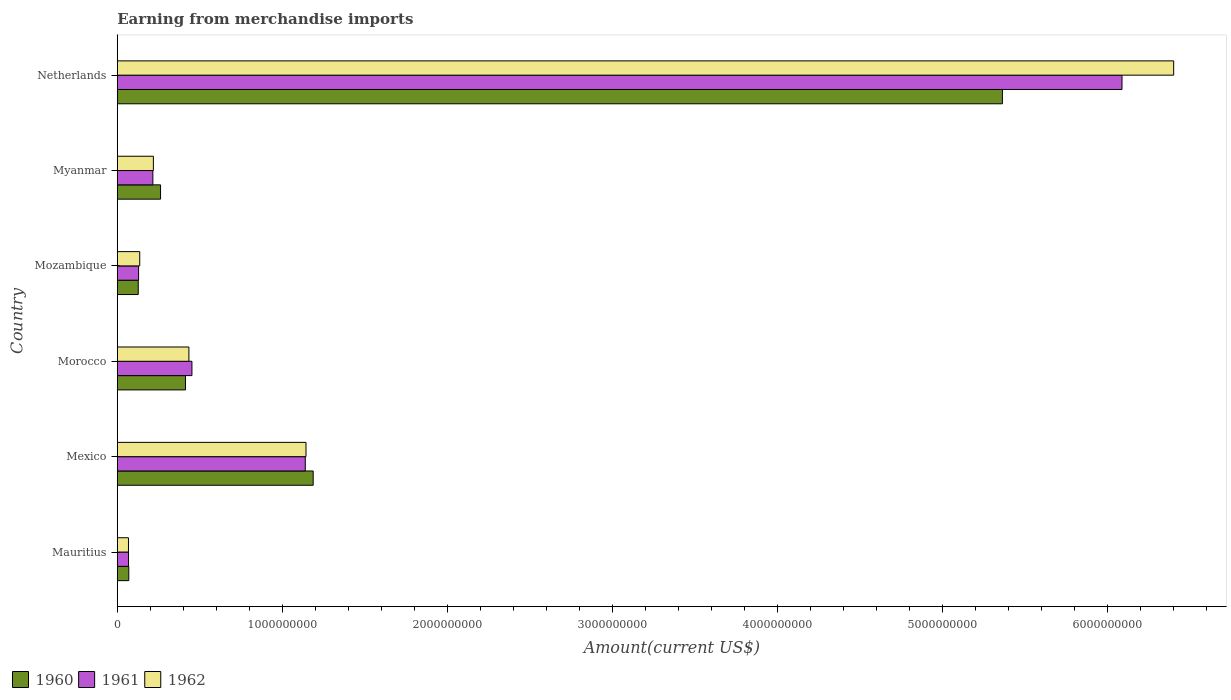How many different coloured bars are there?
Ensure brevity in your answer.  3. Are the number of bars on each tick of the Y-axis equal?
Provide a short and direct response. Yes. How many bars are there on the 4th tick from the top?
Your answer should be compact. 3. How many bars are there on the 5th tick from the bottom?
Make the answer very short. 3. What is the label of the 6th group of bars from the top?
Provide a short and direct response. Mauritius. In how many cases, is the number of bars for a given country not equal to the number of legend labels?
Your answer should be very brief. 0. What is the amount earned from merchandise imports in 1960 in Mozambique?
Your answer should be very brief. 1.27e+08. Across all countries, what is the maximum amount earned from merchandise imports in 1961?
Keep it short and to the point. 6.09e+09. Across all countries, what is the minimum amount earned from merchandise imports in 1961?
Provide a short and direct response. 6.80e+07. In which country was the amount earned from merchandise imports in 1961 minimum?
Give a very brief answer. Mauritius. What is the total amount earned from merchandise imports in 1962 in the graph?
Offer a terse response. 8.40e+09. What is the difference between the amount earned from merchandise imports in 1961 in Mozambique and that in Netherlands?
Keep it short and to the point. -5.96e+09. What is the difference between the amount earned from merchandise imports in 1960 in Myanmar and the amount earned from merchandise imports in 1961 in Netherlands?
Give a very brief answer. -5.82e+09. What is the average amount earned from merchandise imports in 1961 per country?
Offer a very short reply. 1.35e+09. What is the difference between the amount earned from merchandise imports in 1961 and amount earned from merchandise imports in 1960 in Mexico?
Offer a very short reply. -4.78e+07. What is the ratio of the amount earned from merchandise imports in 1961 in Morocco to that in Netherlands?
Make the answer very short. 0.07. Is the amount earned from merchandise imports in 1962 in Morocco less than that in Myanmar?
Your answer should be compact. No. Is the difference between the amount earned from merchandise imports in 1961 in Mexico and Morocco greater than the difference between the amount earned from merchandise imports in 1960 in Mexico and Morocco?
Your answer should be very brief. No. What is the difference between the highest and the second highest amount earned from merchandise imports in 1961?
Provide a succinct answer. 4.95e+09. What is the difference between the highest and the lowest amount earned from merchandise imports in 1960?
Your answer should be very brief. 5.29e+09. In how many countries, is the amount earned from merchandise imports in 1961 greater than the average amount earned from merchandise imports in 1961 taken over all countries?
Offer a terse response. 1. Is the sum of the amount earned from merchandise imports in 1961 in Mauritius and Mexico greater than the maximum amount earned from merchandise imports in 1960 across all countries?
Provide a short and direct response. No. What does the 2nd bar from the top in Mozambique represents?
Your response must be concise. 1961. What does the 3rd bar from the bottom in Mozambique represents?
Your answer should be compact. 1962. What is the difference between two consecutive major ticks on the X-axis?
Provide a succinct answer. 1.00e+09. Does the graph contain any zero values?
Your answer should be very brief. No. Does the graph contain grids?
Ensure brevity in your answer.  No. How many legend labels are there?
Provide a short and direct response. 3. How are the legend labels stacked?
Give a very brief answer. Horizontal. What is the title of the graph?
Your response must be concise. Earning from merchandise imports. What is the label or title of the X-axis?
Give a very brief answer. Amount(current US$). What is the Amount(current US$) of 1960 in Mauritius?
Provide a short and direct response. 6.97e+07. What is the Amount(current US$) of 1961 in Mauritius?
Your answer should be very brief. 6.80e+07. What is the Amount(current US$) in 1962 in Mauritius?
Ensure brevity in your answer.  6.78e+07. What is the Amount(current US$) of 1960 in Mexico?
Provide a succinct answer. 1.19e+09. What is the Amount(current US$) in 1961 in Mexico?
Ensure brevity in your answer.  1.14e+09. What is the Amount(current US$) in 1962 in Mexico?
Provide a succinct answer. 1.14e+09. What is the Amount(current US$) in 1960 in Morocco?
Keep it short and to the point. 4.13e+08. What is the Amount(current US$) of 1961 in Morocco?
Provide a short and direct response. 4.52e+08. What is the Amount(current US$) in 1962 in Morocco?
Keep it short and to the point. 4.34e+08. What is the Amount(current US$) in 1960 in Mozambique?
Make the answer very short. 1.27e+08. What is the Amount(current US$) in 1961 in Mozambique?
Your answer should be compact. 1.29e+08. What is the Amount(current US$) of 1962 in Mozambique?
Your answer should be very brief. 1.36e+08. What is the Amount(current US$) in 1960 in Myanmar?
Make the answer very short. 2.62e+08. What is the Amount(current US$) in 1961 in Myanmar?
Your answer should be very brief. 2.16e+08. What is the Amount(current US$) in 1962 in Myanmar?
Make the answer very short. 2.19e+08. What is the Amount(current US$) of 1960 in Netherlands?
Your response must be concise. 5.36e+09. What is the Amount(current US$) of 1961 in Netherlands?
Your answer should be very brief. 6.09e+09. What is the Amount(current US$) in 1962 in Netherlands?
Make the answer very short. 6.40e+09. Across all countries, what is the maximum Amount(current US$) of 1960?
Make the answer very short. 5.36e+09. Across all countries, what is the maximum Amount(current US$) of 1961?
Offer a very short reply. 6.09e+09. Across all countries, what is the maximum Amount(current US$) in 1962?
Your answer should be compact. 6.40e+09. Across all countries, what is the minimum Amount(current US$) of 1960?
Your response must be concise. 6.97e+07. Across all countries, what is the minimum Amount(current US$) in 1961?
Offer a very short reply. 6.80e+07. Across all countries, what is the minimum Amount(current US$) of 1962?
Your answer should be compact. 6.78e+07. What is the total Amount(current US$) of 1960 in the graph?
Offer a very short reply. 7.42e+09. What is the total Amount(current US$) in 1961 in the graph?
Provide a short and direct response. 8.09e+09. What is the total Amount(current US$) of 1962 in the graph?
Offer a very short reply. 8.40e+09. What is the difference between the Amount(current US$) of 1960 in Mauritius and that in Mexico?
Offer a very short reply. -1.12e+09. What is the difference between the Amount(current US$) in 1961 in Mauritius and that in Mexico?
Offer a very short reply. -1.07e+09. What is the difference between the Amount(current US$) of 1962 in Mauritius and that in Mexico?
Offer a very short reply. -1.08e+09. What is the difference between the Amount(current US$) of 1960 in Mauritius and that in Morocco?
Provide a short and direct response. -3.43e+08. What is the difference between the Amount(current US$) of 1961 in Mauritius and that in Morocco?
Provide a succinct answer. -3.84e+08. What is the difference between the Amount(current US$) in 1962 in Mauritius and that in Morocco?
Offer a terse response. -3.66e+08. What is the difference between the Amount(current US$) of 1960 in Mauritius and that in Mozambique?
Your answer should be compact. -5.73e+07. What is the difference between the Amount(current US$) of 1961 in Mauritius and that in Mozambique?
Offer a very short reply. -6.10e+07. What is the difference between the Amount(current US$) of 1962 in Mauritius and that in Mozambique?
Your answer should be very brief. -6.82e+07. What is the difference between the Amount(current US$) of 1960 in Mauritius and that in Myanmar?
Your answer should be very brief. -1.92e+08. What is the difference between the Amount(current US$) of 1961 in Mauritius and that in Myanmar?
Provide a succinct answer. -1.47e+08. What is the difference between the Amount(current US$) in 1962 in Mauritius and that in Myanmar?
Provide a short and direct response. -1.51e+08. What is the difference between the Amount(current US$) of 1960 in Mauritius and that in Netherlands?
Keep it short and to the point. -5.29e+09. What is the difference between the Amount(current US$) in 1961 in Mauritius and that in Netherlands?
Offer a very short reply. -6.02e+09. What is the difference between the Amount(current US$) of 1962 in Mauritius and that in Netherlands?
Keep it short and to the point. -6.33e+09. What is the difference between the Amount(current US$) of 1960 in Mexico and that in Morocco?
Provide a short and direct response. 7.73e+08. What is the difference between the Amount(current US$) in 1961 in Mexico and that in Morocco?
Give a very brief answer. 6.87e+08. What is the difference between the Amount(current US$) of 1962 in Mexico and that in Morocco?
Offer a terse response. 7.09e+08. What is the difference between the Amount(current US$) of 1960 in Mexico and that in Mozambique?
Keep it short and to the point. 1.06e+09. What is the difference between the Amount(current US$) of 1961 in Mexico and that in Mozambique?
Make the answer very short. 1.01e+09. What is the difference between the Amount(current US$) of 1962 in Mexico and that in Mozambique?
Your answer should be compact. 1.01e+09. What is the difference between the Amount(current US$) of 1960 in Mexico and that in Myanmar?
Offer a terse response. 9.24e+08. What is the difference between the Amount(current US$) of 1961 in Mexico and that in Myanmar?
Offer a terse response. 9.23e+08. What is the difference between the Amount(current US$) in 1962 in Mexico and that in Myanmar?
Offer a very short reply. 9.24e+08. What is the difference between the Amount(current US$) in 1960 in Mexico and that in Netherlands?
Give a very brief answer. -4.17e+09. What is the difference between the Amount(current US$) of 1961 in Mexico and that in Netherlands?
Keep it short and to the point. -4.95e+09. What is the difference between the Amount(current US$) in 1962 in Mexico and that in Netherlands?
Provide a short and direct response. -5.26e+09. What is the difference between the Amount(current US$) of 1960 in Morocco and that in Mozambique?
Offer a terse response. 2.86e+08. What is the difference between the Amount(current US$) in 1961 in Morocco and that in Mozambique?
Ensure brevity in your answer.  3.23e+08. What is the difference between the Amount(current US$) of 1962 in Morocco and that in Mozambique?
Provide a succinct answer. 2.98e+08. What is the difference between the Amount(current US$) of 1960 in Morocco and that in Myanmar?
Provide a short and direct response. 1.51e+08. What is the difference between the Amount(current US$) of 1961 in Morocco and that in Myanmar?
Keep it short and to the point. 2.37e+08. What is the difference between the Amount(current US$) of 1962 in Morocco and that in Myanmar?
Give a very brief answer. 2.15e+08. What is the difference between the Amount(current US$) in 1960 in Morocco and that in Netherlands?
Your response must be concise. -4.95e+09. What is the difference between the Amount(current US$) of 1961 in Morocco and that in Netherlands?
Your answer should be compact. -5.63e+09. What is the difference between the Amount(current US$) of 1962 in Morocco and that in Netherlands?
Your answer should be very brief. -5.96e+09. What is the difference between the Amount(current US$) of 1960 in Mozambique and that in Myanmar?
Ensure brevity in your answer.  -1.35e+08. What is the difference between the Amount(current US$) of 1961 in Mozambique and that in Myanmar?
Make the answer very short. -8.65e+07. What is the difference between the Amount(current US$) of 1962 in Mozambique and that in Myanmar?
Offer a terse response. -8.26e+07. What is the difference between the Amount(current US$) in 1960 in Mozambique and that in Netherlands?
Offer a terse response. -5.23e+09. What is the difference between the Amount(current US$) in 1961 in Mozambique and that in Netherlands?
Provide a succinct answer. -5.96e+09. What is the difference between the Amount(current US$) of 1962 in Mozambique and that in Netherlands?
Provide a short and direct response. -6.26e+09. What is the difference between the Amount(current US$) of 1960 in Myanmar and that in Netherlands?
Your answer should be compact. -5.10e+09. What is the difference between the Amount(current US$) in 1961 in Myanmar and that in Netherlands?
Ensure brevity in your answer.  -5.87e+09. What is the difference between the Amount(current US$) in 1962 in Myanmar and that in Netherlands?
Provide a succinct answer. -6.18e+09. What is the difference between the Amount(current US$) of 1960 in Mauritius and the Amount(current US$) of 1961 in Mexico?
Ensure brevity in your answer.  -1.07e+09. What is the difference between the Amount(current US$) in 1960 in Mauritius and the Amount(current US$) in 1962 in Mexico?
Your answer should be very brief. -1.07e+09. What is the difference between the Amount(current US$) in 1961 in Mauritius and the Amount(current US$) in 1962 in Mexico?
Keep it short and to the point. -1.07e+09. What is the difference between the Amount(current US$) in 1960 in Mauritius and the Amount(current US$) in 1961 in Morocco?
Provide a short and direct response. -3.82e+08. What is the difference between the Amount(current US$) in 1960 in Mauritius and the Amount(current US$) in 1962 in Morocco?
Ensure brevity in your answer.  -3.64e+08. What is the difference between the Amount(current US$) in 1961 in Mauritius and the Amount(current US$) in 1962 in Morocco?
Your response must be concise. -3.66e+08. What is the difference between the Amount(current US$) in 1960 in Mauritius and the Amount(current US$) in 1961 in Mozambique?
Keep it short and to the point. -5.93e+07. What is the difference between the Amount(current US$) in 1960 in Mauritius and the Amount(current US$) in 1962 in Mozambique?
Offer a very short reply. -6.63e+07. What is the difference between the Amount(current US$) of 1961 in Mauritius and the Amount(current US$) of 1962 in Mozambique?
Your answer should be compact. -6.80e+07. What is the difference between the Amount(current US$) of 1960 in Mauritius and the Amount(current US$) of 1961 in Myanmar?
Offer a very short reply. -1.46e+08. What is the difference between the Amount(current US$) of 1960 in Mauritius and the Amount(current US$) of 1962 in Myanmar?
Your answer should be very brief. -1.49e+08. What is the difference between the Amount(current US$) in 1961 in Mauritius and the Amount(current US$) in 1962 in Myanmar?
Make the answer very short. -1.51e+08. What is the difference between the Amount(current US$) in 1960 in Mauritius and the Amount(current US$) in 1961 in Netherlands?
Give a very brief answer. -6.02e+09. What is the difference between the Amount(current US$) of 1960 in Mauritius and the Amount(current US$) of 1962 in Netherlands?
Provide a succinct answer. -6.33e+09. What is the difference between the Amount(current US$) of 1961 in Mauritius and the Amount(current US$) of 1962 in Netherlands?
Your response must be concise. -6.33e+09. What is the difference between the Amount(current US$) in 1960 in Mexico and the Amount(current US$) in 1961 in Morocco?
Your answer should be compact. 7.34e+08. What is the difference between the Amount(current US$) in 1960 in Mexico and the Amount(current US$) in 1962 in Morocco?
Give a very brief answer. 7.53e+08. What is the difference between the Amount(current US$) of 1961 in Mexico and the Amount(current US$) of 1962 in Morocco?
Ensure brevity in your answer.  7.05e+08. What is the difference between the Amount(current US$) of 1960 in Mexico and the Amount(current US$) of 1961 in Mozambique?
Give a very brief answer. 1.06e+09. What is the difference between the Amount(current US$) in 1960 in Mexico and the Amount(current US$) in 1962 in Mozambique?
Your answer should be compact. 1.05e+09. What is the difference between the Amount(current US$) of 1961 in Mexico and the Amount(current US$) of 1962 in Mozambique?
Offer a very short reply. 1.00e+09. What is the difference between the Amount(current US$) of 1960 in Mexico and the Amount(current US$) of 1961 in Myanmar?
Your answer should be compact. 9.71e+08. What is the difference between the Amount(current US$) in 1960 in Mexico and the Amount(current US$) in 1962 in Myanmar?
Offer a terse response. 9.68e+08. What is the difference between the Amount(current US$) in 1961 in Mexico and the Amount(current US$) in 1962 in Myanmar?
Provide a short and direct response. 9.20e+08. What is the difference between the Amount(current US$) of 1960 in Mexico and the Amount(current US$) of 1961 in Netherlands?
Offer a terse response. -4.90e+09. What is the difference between the Amount(current US$) in 1960 in Mexico and the Amount(current US$) in 1962 in Netherlands?
Ensure brevity in your answer.  -5.21e+09. What is the difference between the Amount(current US$) in 1961 in Mexico and the Amount(current US$) in 1962 in Netherlands?
Ensure brevity in your answer.  -5.26e+09. What is the difference between the Amount(current US$) in 1960 in Morocco and the Amount(current US$) in 1961 in Mozambique?
Keep it short and to the point. 2.84e+08. What is the difference between the Amount(current US$) of 1960 in Morocco and the Amount(current US$) of 1962 in Mozambique?
Ensure brevity in your answer.  2.77e+08. What is the difference between the Amount(current US$) in 1961 in Morocco and the Amount(current US$) in 1962 in Mozambique?
Ensure brevity in your answer.  3.16e+08. What is the difference between the Amount(current US$) of 1960 in Morocco and the Amount(current US$) of 1961 in Myanmar?
Offer a very short reply. 1.97e+08. What is the difference between the Amount(current US$) of 1960 in Morocco and the Amount(current US$) of 1962 in Myanmar?
Ensure brevity in your answer.  1.94e+08. What is the difference between the Amount(current US$) in 1961 in Morocco and the Amount(current US$) in 1962 in Myanmar?
Keep it short and to the point. 2.33e+08. What is the difference between the Amount(current US$) of 1960 in Morocco and the Amount(current US$) of 1961 in Netherlands?
Your answer should be very brief. -5.67e+09. What is the difference between the Amount(current US$) in 1960 in Morocco and the Amount(current US$) in 1962 in Netherlands?
Keep it short and to the point. -5.99e+09. What is the difference between the Amount(current US$) in 1961 in Morocco and the Amount(current US$) in 1962 in Netherlands?
Make the answer very short. -5.95e+09. What is the difference between the Amount(current US$) of 1960 in Mozambique and the Amount(current US$) of 1961 in Myanmar?
Keep it short and to the point. -8.85e+07. What is the difference between the Amount(current US$) of 1960 in Mozambique and the Amount(current US$) of 1962 in Myanmar?
Give a very brief answer. -9.16e+07. What is the difference between the Amount(current US$) of 1961 in Mozambique and the Amount(current US$) of 1962 in Myanmar?
Your answer should be very brief. -8.96e+07. What is the difference between the Amount(current US$) of 1960 in Mozambique and the Amount(current US$) of 1961 in Netherlands?
Give a very brief answer. -5.96e+09. What is the difference between the Amount(current US$) of 1960 in Mozambique and the Amount(current US$) of 1962 in Netherlands?
Provide a short and direct response. -6.27e+09. What is the difference between the Amount(current US$) in 1961 in Mozambique and the Amount(current US$) in 1962 in Netherlands?
Your answer should be compact. -6.27e+09. What is the difference between the Amount(current US$) of 1960 in Myanmar and the Amount(current US$) of 1961 in Netherlands?
Give a very brief answer. -5.82e+09. What is the difference between the Amount(current US$) in 1960 in Myanmar and the Amount(current US$) in 1962 in Netherlands?
Give a very brief answer. -6.14e+09. What is the difference between the Amount(current US$) in 1961 in Myanmar and the Amount(current US$) in 1962 in Netherlands?
Keep it short and to the point. -6.18e+09. What is the average Amount(current US$) in 1960 per country?
Offer a very short reply. 1.24e+09. What is the average Amount(current US$) in 1961 per country?
Give a very brief answer. 1.35e+09. What is the average Amount(current US$) of 1962 per country?
Offer a very short reply. 1.40e+09. What is the difference between the Amount(current US$) of 1960 and Amount(current US$) of 1961 in Mauritius?
Your answer should be compact. 1.66e+06. What is the difference between the Amount(current US$) in 1960 and Amount(current US$) in 1962 in Mauritius?
Keep it short and to the point. 1.93e+06. What is the difference between the Amount(current US$) in 1961 and Amount(current US$) in 1962 in Mauritius?
Keep it short and to the point. 2.73e+05. What is the difference between the Amount(current US$) of 1960 and Amount(current US$) of 1961 in Mexico?
Your answer should be compact. 4.78e+07. What is the difference between the Amount(current US$) in 1960 and Amount(current US$) in 1962 in Mexico?
Provide a short and direct response. 4.34e+07. What is the difference between the Amount(current US$) in 1961 and Amount(current US$) in 1962 in Mexico?
Your answer should be compact. -4.40e+06. What is the difference between the Amount(current US$) in 1960 and Amount(current US$) in 1961 in Morocco?
Give a very brief answer. -3.91e+07. What is the difference between the Amount(current US$) of 1960 and Amount(current US$) of 1962 in Morocco?
Make the answer very short. -2.07e+07. What is the difference between the Amount(current US$) in 1961 and Amount(current US$) in 1962 in Morocco?
Offer a very short reply. 1.84e+07. What is the difference between the Amount(current US$) of 1960 and Amount(current US$) of 1962 in Mozambique?
Keep it short and to the point. -9.00e+06. What is the difference between the Amount(current US$) in 1961 and Amount(current US$) in 1962 in Mozambique?
Keep it short and to the point. -7.00e+06. What is the difference between the Amount(current US$) in 1960 and Amount(current US$) in 1961 in Myanmar?
Provide a succinct answer. 4.65e+07. What is the difference between the Amount(current US$) of 1960 and Amount(current US$) of 1962 in Myanmar?
Provide a short and direct response. 4.34e+07. What is the difference between the Amount(current US$) of 1961 and Amount(current US$) of 1962 in Myanmar?
Your response must be concise. -3.11e+06. What is the difference between the Amount(current US$) of 1960 and Amount(current US$) of 1961 in Netherlands?
Offer a very short reply. -7.24e+08. What is the difference between the Amount(current US$) of 1960 and Amount(current US$) of 1962 in Netherlands?
Keep it short and to the point. -1.04e+09. What is the difference between the Amount(current US$) in 1961 and Amount(current US$) in 1962 in Netherlands?
Provide a succinct answer. -3.13e+08. What is the ratio of the Amount(current US$) in 1960 in Mauritius to that in Mexico?
Your answer should be very brief. 0.06. What is the ratio of the Amount(current US$) in 1961 in Mauritius to that in Mexico?
Your answer should be very brief. 0.06. What is the ratio of the Amount(current US$) of 1962 in Mauritius to that in Mexico?
Offer a terse response. 0.06. What is the ratio of the Amount(current US$) of 1960 in Mauritius to that in Morocco?
Your answer should be compact. 0.17. What is the ratio of the Amount(current US$) of 1961 in Mauritius to that in Morocco?
Offer a terse response. 0.15. What is the ratio of the Amount(current US$) in 1962 in Mauritius to that in Morocco?
Keep it short and to the point. 0.16. What is the ratio of the Amount(current US$) of 1960 in Mauritius to that in Mozambique?
Ensure brevity in your answer.  0.55. What is the ratio of the Amount(current US$) of 1961 in Mauritius to that in Mozambique?
Ensure brevity in your answer.  0.53. What is the ratio of the Amount(current US$) of 1962 in Mauritius to that in Mozambique?
Keep it short and to the point. 0.5. What is the ratio of the Amount(current US$) of 1960 in Mauritius to that in Myanmar?
Your answer should be very brief. 0.27. What is the ratio of the Amount(current US$) in 1961 in Mauritius to that in Myanmar?
Your answer should be compact. 0.32. What is the ratio of the Amount(current US$) of 1962 in Mauritius to that in Myanmar?
Offer a very short reply. 0.31. What is the ratio of the Amount(current US$) in 1960 in Mauritius to that in Netherlands?
Make the answer very short. 0.01. What is the ratio of the Amount(current US$) of 1961 in Mauritius to that in Netherlands?
Offer a terse response. 0.01. What is the ratio of the Amount(current US$) of 1962 in Mauritius to that in Netherlands?
Ensure brevity in your answer.  0.01. What is the ratio of the Amount(current US$) in 1960 in Mexico to that in Morocco?
Offer a terse response. 2.87. What is the ratio of the Amount(current US$) in 1961 in Mexico to that in Morocco?
Your answer should be compact. 2.52. What is the ratio of the Amount(current US$) in 1962 in Mexico to that in Morocco?
Offer a terse response. 2.64. What is the ratio of the Amount(current US$) in 1960 in Mexico to that in Mozambique?
Ensure brevity in your answer.  9.34. What is the ratio of the Amount(current US$) in 1961 in Mexico to that in Mozambique?
Give a very brief answer. 8.83. What is the ratio of the Amount(current US$) in 1962 in Mexico to that in Mozambique?
Offer a very short reply. 8.4. What is the ratio of the Amount(current US$) in 1960 in Mexico to that in Myanmar?
Give a very brief answer. 4.53. What is the ratio of the Amount(current US$) in 1961 in Mexico to that in Myanmar?
Offer a very short reply. 5.28. What is the ratio of the Amount(current US$) of 1962 in Mexico to that in Myanmar?
Your response must be concise. 5.23. What is the ratio of the Amount(current US$) in 1960 in Mexico to that in Netherlands?
Provide a succinct answer. 0.22. What is the ratio of the Amount(current US$) of 1961 in Mexico to that in Netherlands?
Make the answer very short. 0.19. What is the ratio of the Amount(current US$) in 1962 in Mexico to that in Netherlands?
Provide a succinct answer. 0.18. What is the ratio of the Amount(current US$) in 1960 in Morocco to that in Mozambique?
Your response must be concise. 3.25. What is the ratio of the Amount(current US$) in 1961 in Morocco to that in Mozambique?
Offer a very short reply. 3.5. What is the ratio of the Amount(current US$) of 1962 in Morocco to that in Mozambique?
Give a very brief answer. 3.19. What is the ratio of the Amount(current US$) of 1960 in Morocco to that in Myanmar?
Provide a succinct answer. 1.58. What is the ratio of the Amount(current US$) of 1961 in Morocco to that in Myanmar?
Your response must be concise. 2.1. What is the ratio of the Amount(current US$) of 1962 in Morocco to that in Myanmar?
Make the answer very short. 1.98. What is the ratio of the Amount(current US$) of 1960 in Morocco to that in Netherlands?
Offer a very short reply. 0.08. What is the ratio of the Amount(current US$) in 1961 in Morocco to that in Netherlands?
Offer a terse response. 0.07. What is the ratio of the Amount(current US$) in 1962 in Morocco to that in Netherlands?
Your answer should be compact. 0.07. What is the ratio of the Amount(current US$) of 1960 in Mozambique to that in Myanmar?
Provide a short and direct response. 0.48. What is the ratio of the Amount(current US$) of 1961 in Mozambique to that in Myanmar?
Your response must be concise. 0.6. What is the ratio of the Amount(current US$) of 1962 in Mozambique to that in Myanmar?
Give a very brief answer. 0.62. What is the ratio of the Amount(current US$) in 1960 in Mozambique to that in Netherlands?
Your answer should be very brief. 0.02. What is the ratio of the Amount(current US$) in 1961 in Mozambique to that in Netherlands?
Offer a very short reply. 0.02. What is the ratio of the Amount(current US$) of 1962 in Mozambique to that in Netherlands?
Offer a very short reply. 0.02. What is the ratio of the Amount(current US$) of 1960 in Myanmar to that in Netherlands?
Offer a terse response. 0.05. What is the ratio of the Amount(current US$) in 1961 in Myanmar to that in Netherlands?
Give a very brief answer. 0.04. What is the ratio of the Amount(current US$) of 1962 in Myanmar to that in Netherlands?
Provide a short and direct response. 0.03. What is the difference between the highest and the second highest Amount(current US$) in 1960?
Your answer should be very brief. 4.17e+09. What is the difference between the highest and the second highest Amount(current US$) in 1961?
Provide a short and direct response. 4.95e+09. What is the difference between the highest and the second highest Amount(current US$) of 1962?
Your answer should be very brief. 5.26e+09. What is the difference between the highest and the lowest Amount(current US$) in 1960?
Ensure brevity in your answer.  5.29e+09. What is the difference between the highest and the lowest Amount(current US$) of 1961?
Offer a very short reply. 6.02e+09. What is the difference between the highest and the lowest Amount(current US$) in 1962?
Provide a succinct answer. 6.33e+09. 